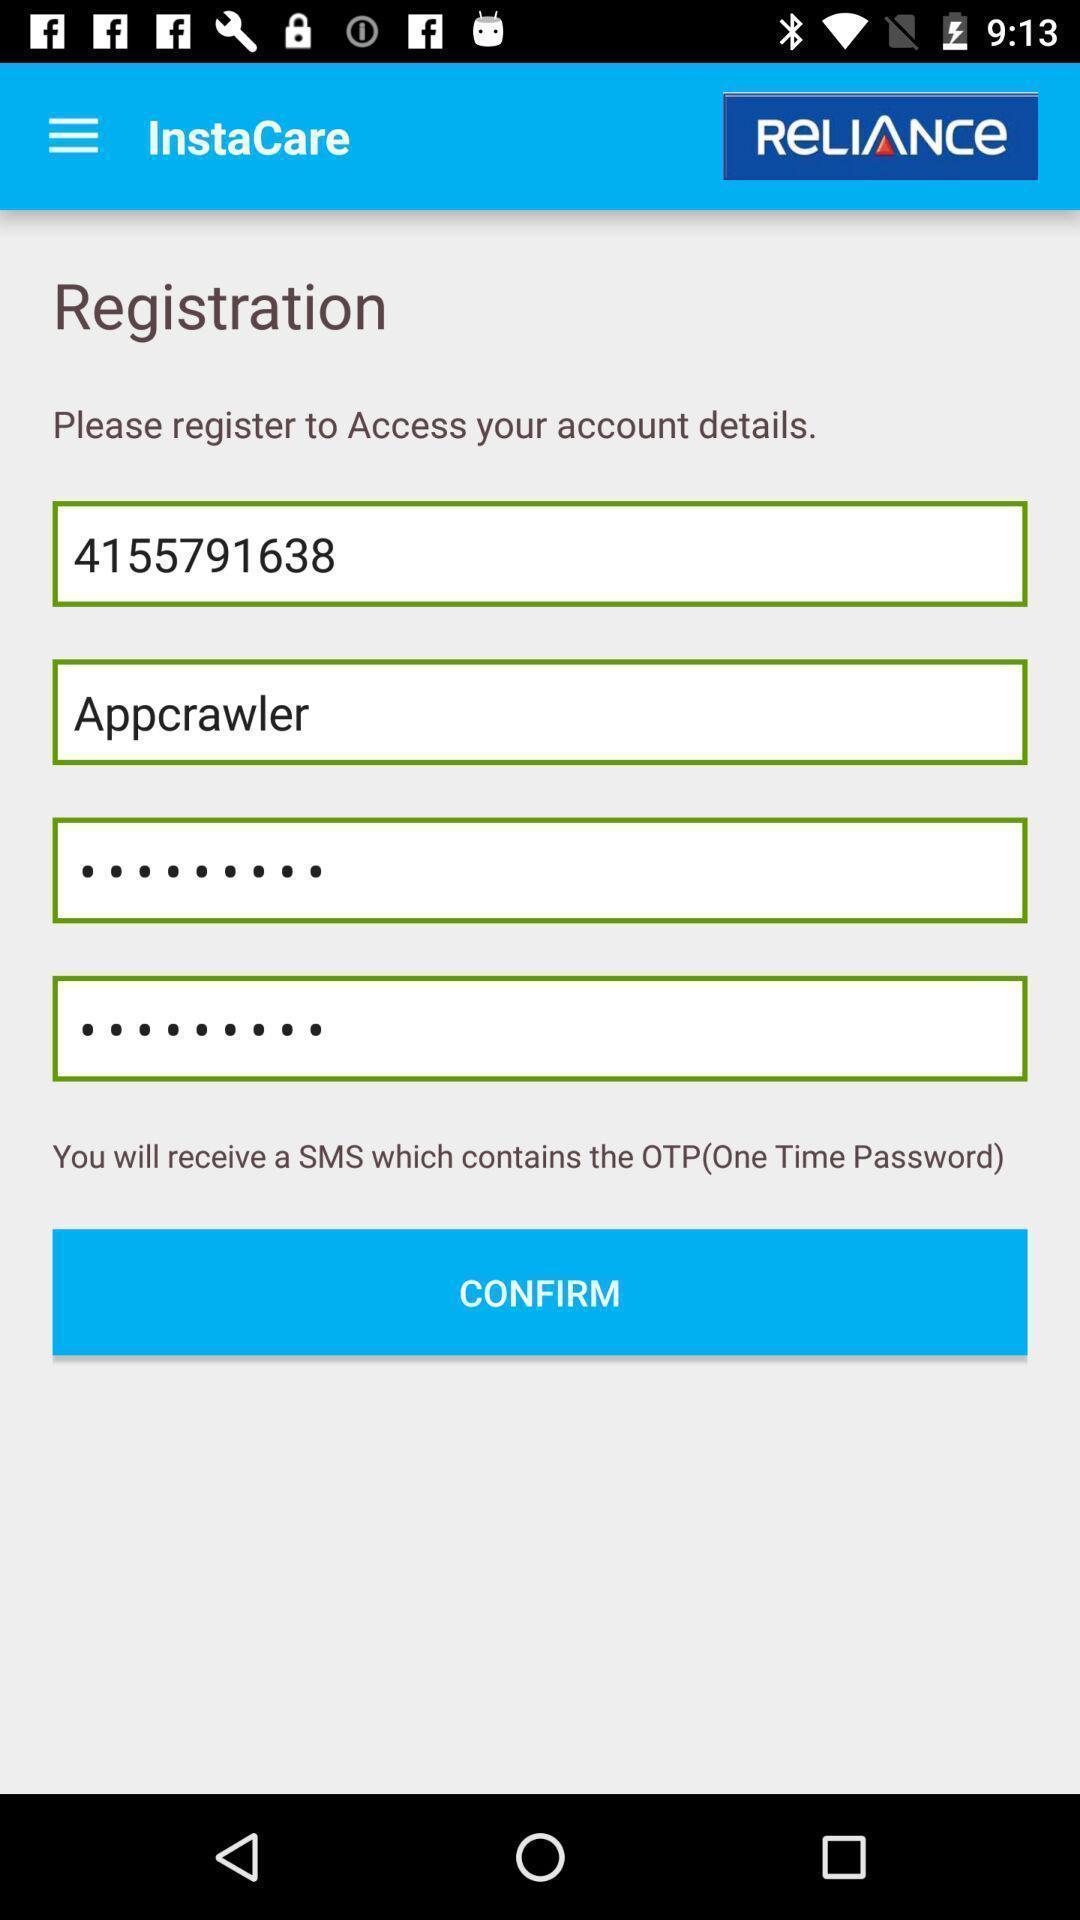Tell me what you see in this picture. Registration page. 